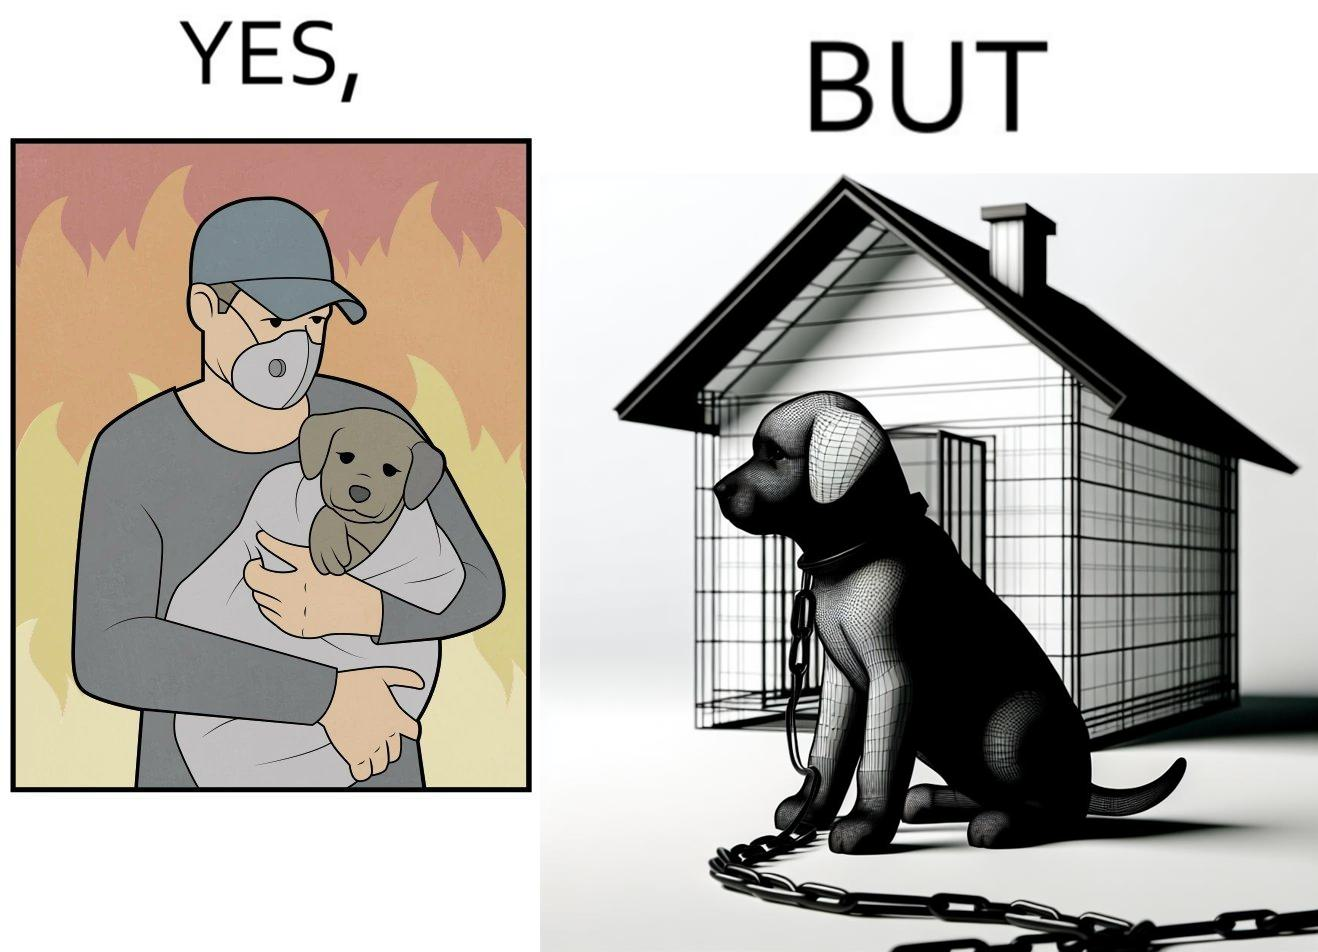Describe what you see in this image. The image is ironic, because in the left image the man is showing love and care for the puppy but in the right image the same puppy is shown to be chained in a kennel, which shows dual nature of human towards animals 